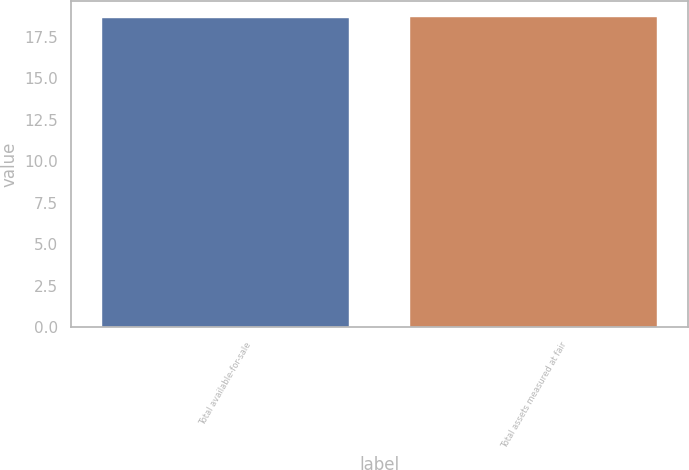Convert chart. <chart><loc_0><loc_0><loc_500><loc_500><bar_chart><fcel>Total available-for-sale<fcel>Total assets measured at fair<nl><fcel>18.6<fcel>18.7<nl></chart> 